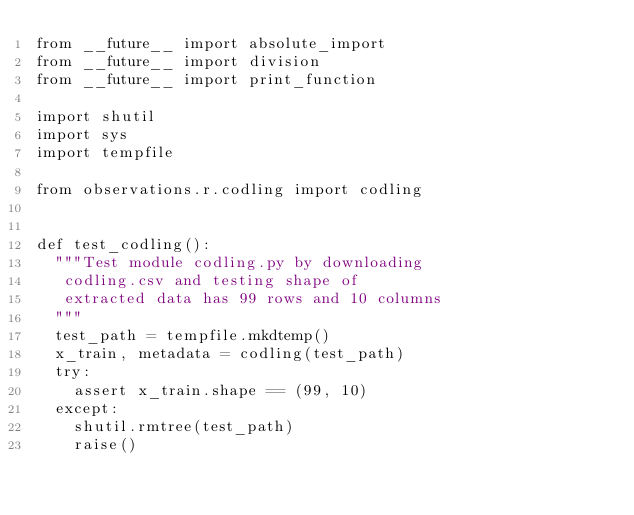Convert code to text. <code><loc_0><loc_0><loc_500><loc_500><_Python_>from __future__ import absolute_import
from __future__ import division
from __future__ import print_function

import shutil
import sys
import tempfile

from observations.r.codling import codling


def test_codling():
  """Test module codling.py by downloading
   codling.csv and testing shape of
   extracted data has 99 rows and 10 columns
  """
  test_path = tempfile.mkdtemp()
  x_train, metadata = codling(test_path)
  try:
    assert x_train.shape == (99, 10)
  except:
    shutil.rmtree(test_path)
    raise()
</code> 